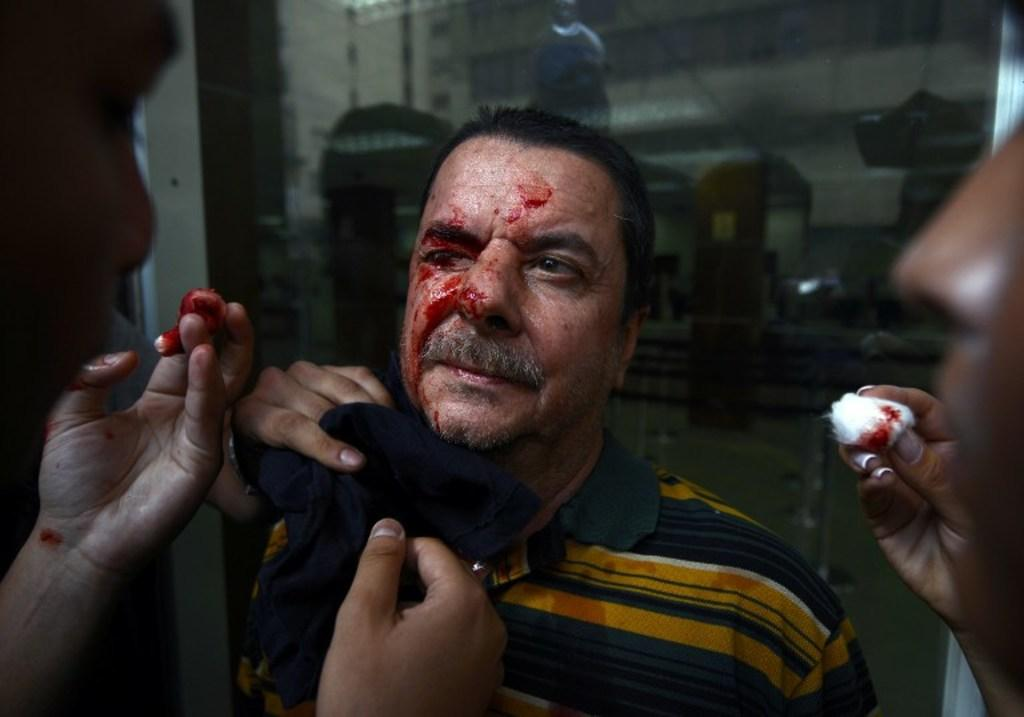What is happening to the person in the center of the image? The person in the center of the image appears to be bleeding. How many other people are visible in the image? There are two other people visible in the image, one on the right side and one on the left side. What is the person on the left side of the image holding? The person on the left side of the image is holding cotton. What can be seen in the background of the image? There is a glass window in the background of the image. What type of drink is being offered to the person on the right side of the image? There is no drink visible in the image, and no one is offering a drink to the person on the right side. 